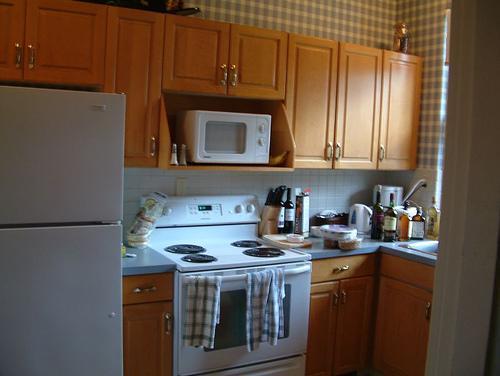How many microwaves can be seen?
Give a very brief answer. 1. How many people are walking up the stairs?
Give a very brief answer. 0. 